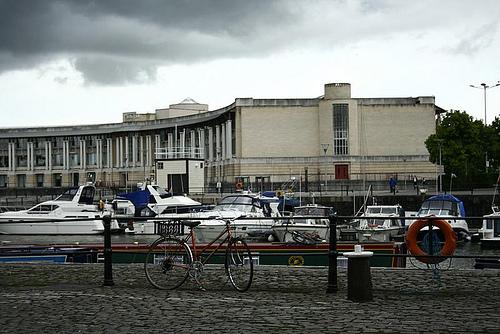What kind of boat is this?
Answer briefly. Motor. Is it sunny?
Concise answer only. No. Is this a flea market?
Answer briefly. No. How many types of vehicles are in the photo?
Keep it brief. 2. How tall is the building?
Write a very short answer. 3 stories. Will it rain?
Answer briefly. Yes. 